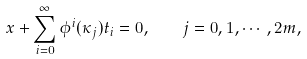Convert formula to latex. <formula><loc_0><loc_0><loc_500><loc_500>x + \sum _ { i = 0 } ^ { \infty } \phi ^ { i } ( \kappa _ { j } ) t _ { i } = 0 , \quad j = 0 , 1 , \cdots , 2 m ,</formula> 